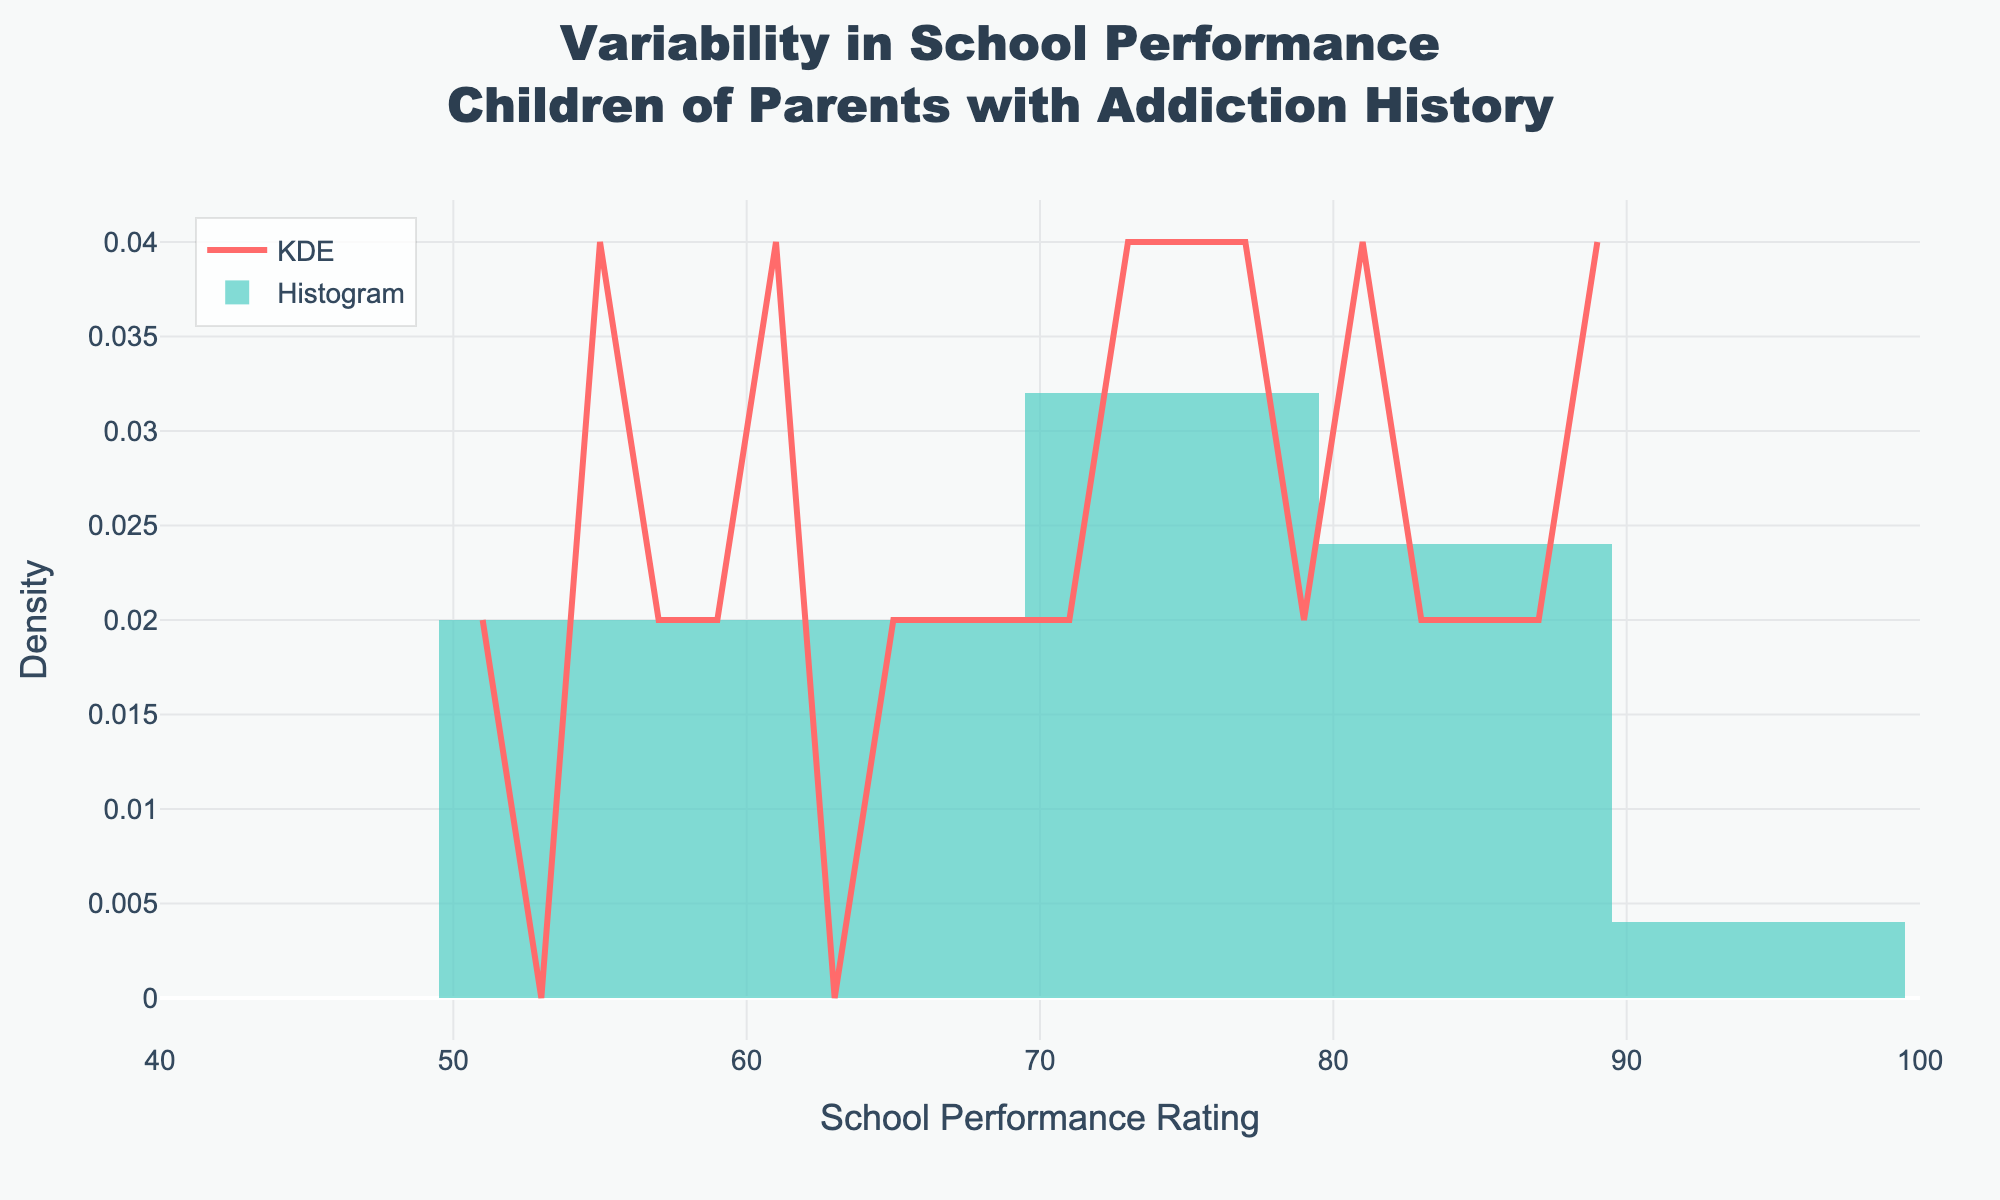what is the title of the figure? Look at the top of the figure where the title is typically located.
Answer: Variability in School Performance<br>Children of Parents with Addiction History what is the range of the x-axis? Check the x-axis labels to see the minimum and maximum values.
Answer: 40 to 100 what color represents the KDE line in the plot? Look for the color of the smooth curve that represents the KDE.
Answer: Red How does the density of school performance ratings differ between the 50-60 and 70-80 ranges? Observe and compare the height of the density curve and histogram bars between the specified ranges.
Answer: Higher density between 70-80 than 50-60 What's the highest density value on the KDE curve and around what performance rating is it observed? Look for the peak of the KDE curve and note the corresponding x-value.
Answer: ~0.025 density around a performance rating of 75 What are the two main visual elements used in the plot? Identify and describe the primary types of plots present in the figure.
Answer: KDE line and histogram How many data points are included in the histogram? Count the individual bars in the histogram or look for a cumulative count if available.
Answer: 25 Does the KDE curve suggest a skew in school performance ratings? Analyze the shape of the KDE curve to determine if it is symmetric or skewed towards any side.
Answer: Slightly skewed to the right How does the histogram illustrate the distribution of school performance ratings? Look at the heights and spread of the histogram bars to understand the distribution pattern.
Answer: Bimodal with peaks around 60 and 80 What does the highest histogram bar represent? (in terms of performance rating range) Identify the tallest bar in the histogram and note the range of values on the x-axis it spans.
Answer: The 60-65 performance rating range 